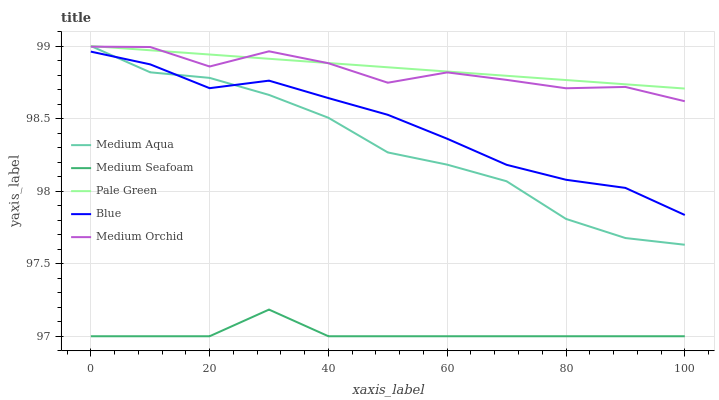Does Medium Seafoam have the minimum area under the curve?
Answer yes or no. Yes. Does Pale Green have the maximum area under the curve?
Answer yes or no. Yes. Does Medium Orchid have the minimum area under the curve?
Answer yes or no. No. Does Medium Orchid have the maximum area under the curve?
Answer yes or no. No. Is Pale Green the smoothest?
Answer yes or no. Yes. Is Medium Orchid the roughest?
Answer yes or no. Yes. Is Medium Orchid the smoothest?
Answer yes or no. No. Is Pale Green the roughest?
Answer yes or no. No. Does Medium Seafoam have the lowest value?
Answer yes or no. Yes. Does Medium Orchid have the lowest value?
Answer yes or no. No. Does Medium Aqua have the highest value?
Answer yes or no. Yes. Does Medium Orchid have the highest value?
Answer yes or no. No. Is Blue less than Medium Orchid?
Answer yes or no. Yes. Is Medium Orchid greater than Blue?
Answer yes or no. Yes. Does Pale Green intersect Medium Orchid?
Answer yes or no. Yes. Is Pale Green less than Medium Orchid?
Answer yes or no. No. Is Pale Green greater than Medium Orchid?
Answer yes or no. No. Does Blue intersect Medium Orchid?
Answer yes or no. No. 